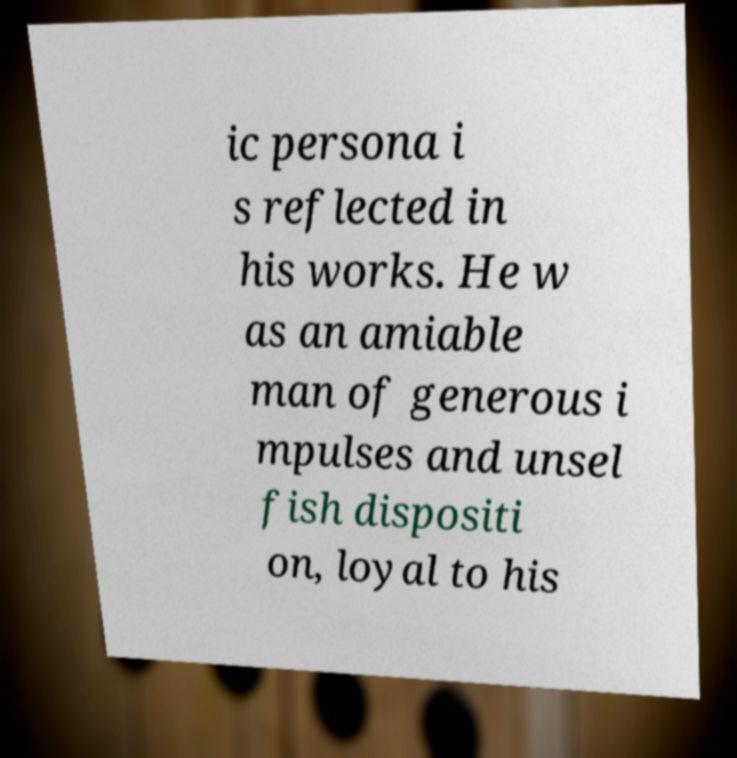Can you read and provide the text displayed in the image?This photo seems to have some interesting text. Can you extract and type it out for me? ic persona i s reflected in his works. He w as an amiable man of generous i mpulses and unsel fish dispositi on, loyal to his 